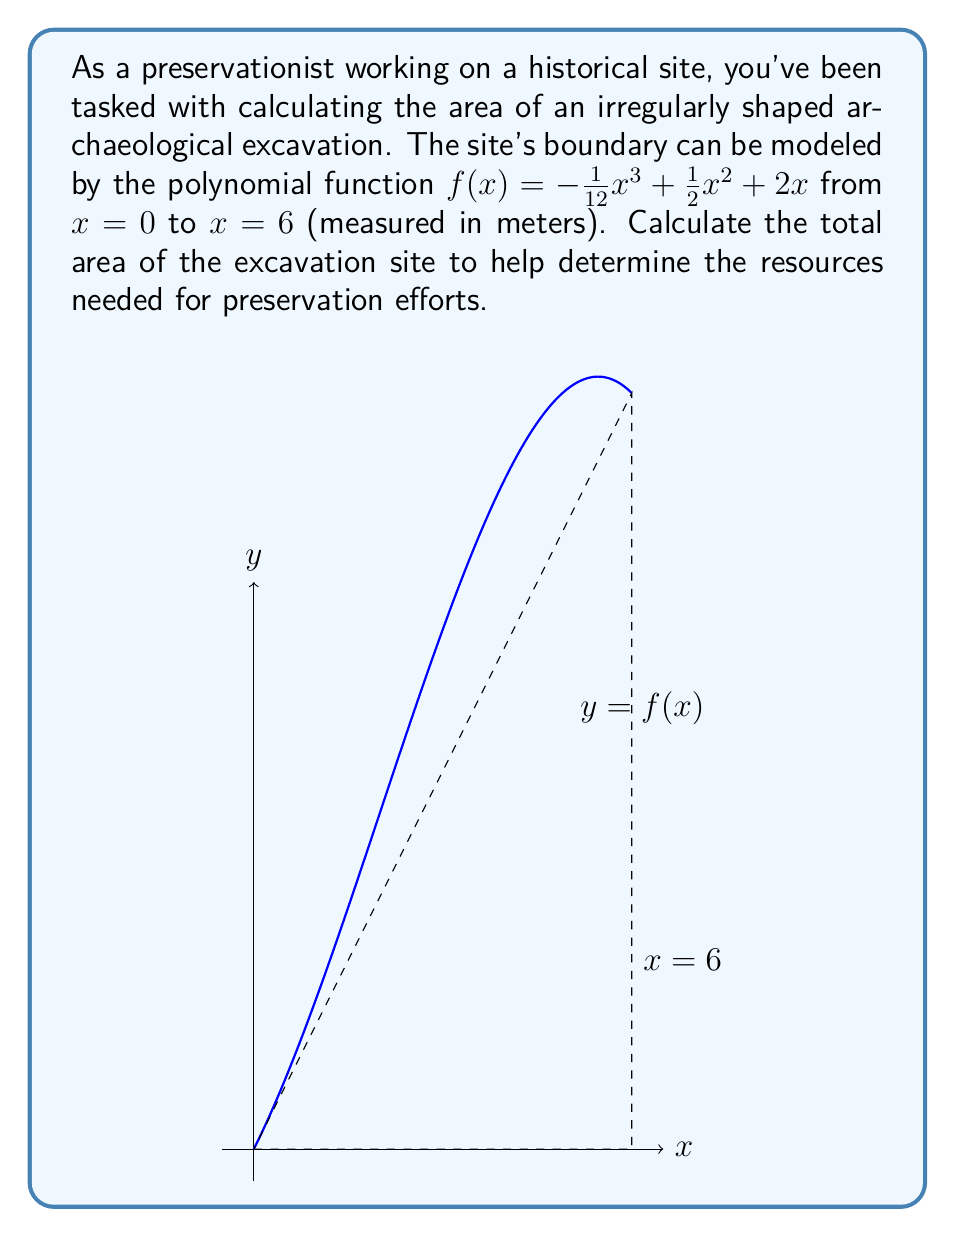What is the answer to this math problem? To calculate the area under the polynomial function, we need to use definite integration. The steps are as follows:

1) The area under the curve is given by the definite integral:

   $$A = \int_0^6 f(x) dx = \int_0^6 (-\frac{1}{12}x^3 + \frac{1}{2}x^2 + 2x) dx$$

2) Integrate the polynomial term by term:

   $$A = [-\frac{1}{48}x^4 + \frac{1}{6}x^3 + x^2]_0^6$$

3) Evaluate the integral at the upper and lower bounds:

   $$A = [-\frac{1}{48}(6^4) + \frac{1}{6}(6^3) + (6^2)] - [-\frac{1}{48}(0^4) + \frac{1}{6}(0^3) + (0^2)]$$

4) Simplify:

   $$A = [-\frac{1296}{48} + 36 + 36] - [0]$$
   
   $$A = [-27 + 36 + 36]$$
   
   $$A = 45$$

Therefore, the total area of the excavation site is 45 square meters.
Answer: 45 square meters 